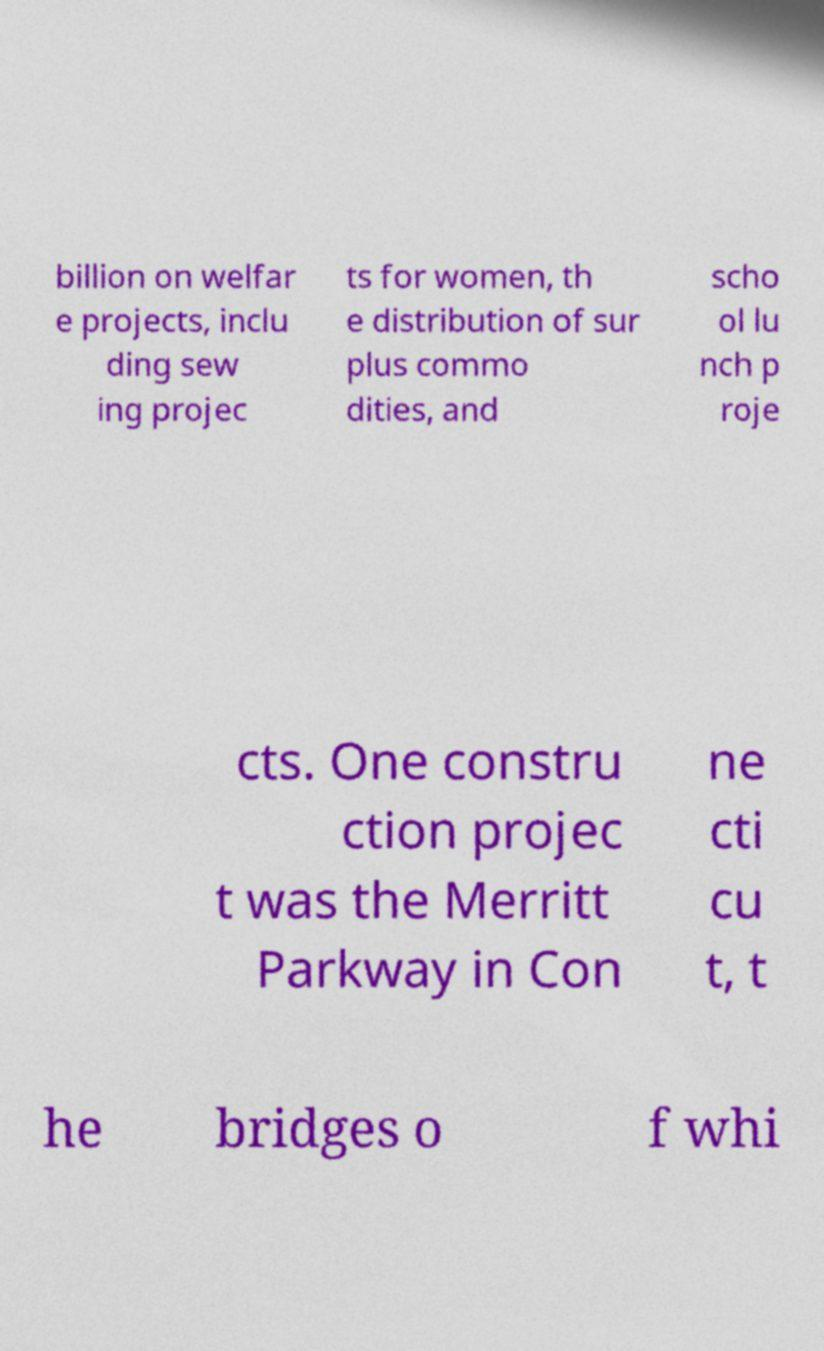There's text embedded in this image that I need extracted. Can you transcribe it verbatim? billion on welfar e projects, inclu ding sew ing projec ts for women, th e distribution of sur plus commo dities, and scho ol lu nch p roje cts. One constru ction projec t was the Merritt Parkway in Con ne cti cu t, t he bridges o f whi 